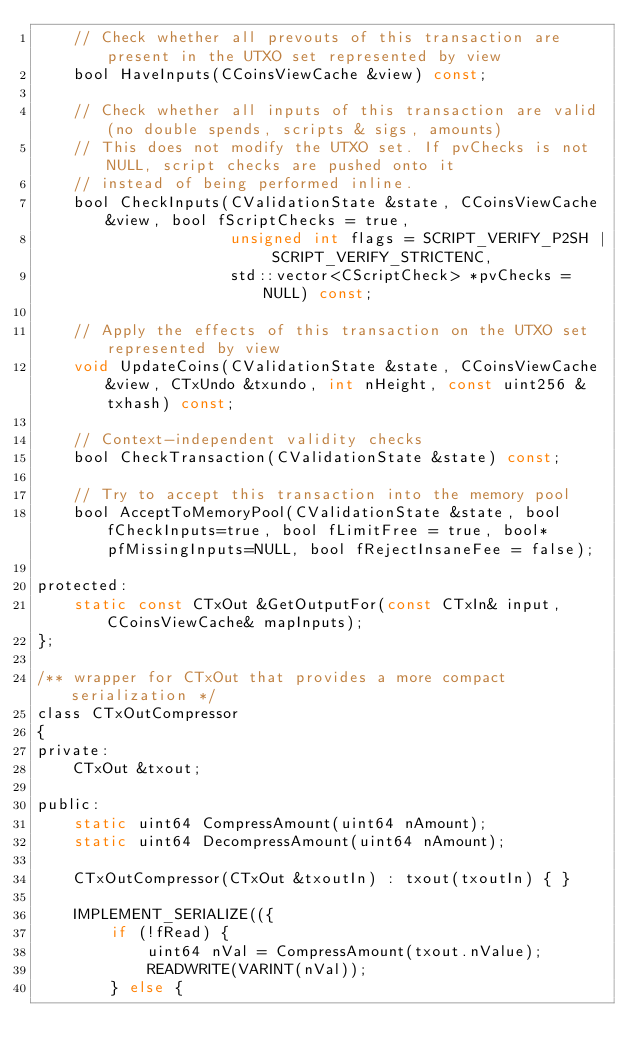<code> <loc_0><loc_0><loc_500><loc_500><_C_>    // Check whether all prevouts of this transaction are present in the UTXO set represented by view
    bool HaveInputs(CCoinsViewCache &view) const;

    // Check whether all inputs of this transaction are valid (no double spends, scripts & sigs, amounts)
    // This does not modify the UTXO set. If pvChecks is not NULL, script checks are pushed onto it
    // instead of being performed inline.
    bool CheckInputs(CValidationState &state, CCoinsViewCache &view, bool fScriptChecks = true,
                     unsigned int flags = SCRIPT_VERIFY_P2SH | SCRIPT_VERIFY_STRICTENC,
                     std::vector<CScriptCheck> *pvChecks = NULL) const;

    // Apply the effects of this transaction on the UTXO set represented by view
    void UpdateCoins(CValidationState &state, CCoinsViewCache &view, CTxUndo &txundo, int nHeight, const uint256 &txhash) const;

    // Context-independent validity checks
    bool CheckTransaction(CValidationState &state) const;

    // Try to accept this transaction into the memory pool
    bool AcceptToMemoryPool(CValidationState &state, bool fCheckInputs=true, bool fLimitFree = true, bool* pfMissingInputs=NULL, bool fRejectInsaneFee = false);

protected:
    static const CTxOut &GetOutputFor(const CTxIn& input, CCoinsViewCache& mapInputs);
};

/** wrapper for CTxOut that provides a more compact serialization */
class CTxOutCompressor
{
private:
    CTxOut &txout;

public:
    static uint64 CompressAmount(uint64 nAmount);
    static uint64 DecompressAmount(uint64 nAmount);

    CTxOutCompressor(CTxOut &txoutIn) : txout(txoutIn) { }

    IMPLEMENT_SERIALIZE(({
        if (!fRead) {
            uint64 nVal = CompressAmount(txout.nValue);
            READWRITE(VARINT(nVal));
        } else {</code> 